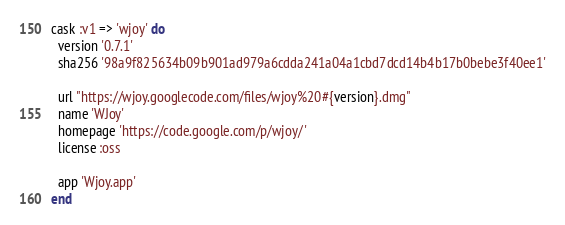Convert code to text. <code><loc_0><loc_0><loc_500><loc_500><_Ruby_>cask :v1 => 'wjoy' do
  version '0.7.1'
  sha256 '98a9f825634b09b901ad979a6cdda241a04a1cbd7dcd14b4b17b0bebe3f40ee1'

  url "https://wjoy.googlecode.com/files/wjoy%20#{version}.dmg"
  name 'WJoy'
  homepage 'https://code.google.com/p/wjoy/'
  license :oss

  app 'Wjoy.app'
end
</code> 